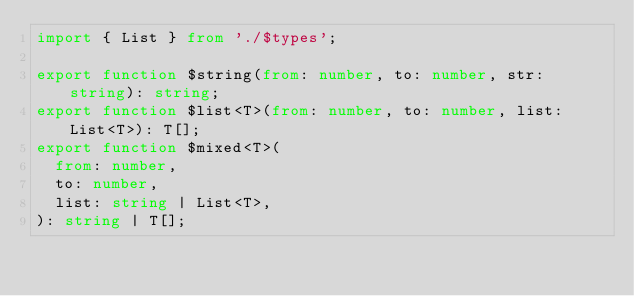Convert code to text. <code><loc_0><loc_0><loc_500><loc_500><_TypeScript_>import { List } from './$types';

export function $string(from: number, to: number, str: string): string;
export function $list<T>(from: number, to: number, list: List<T>): T[];
export function $mixed<T>(
  from: number,
  to: number,
  list: string | List<T>,
): string | T[];
</code> 